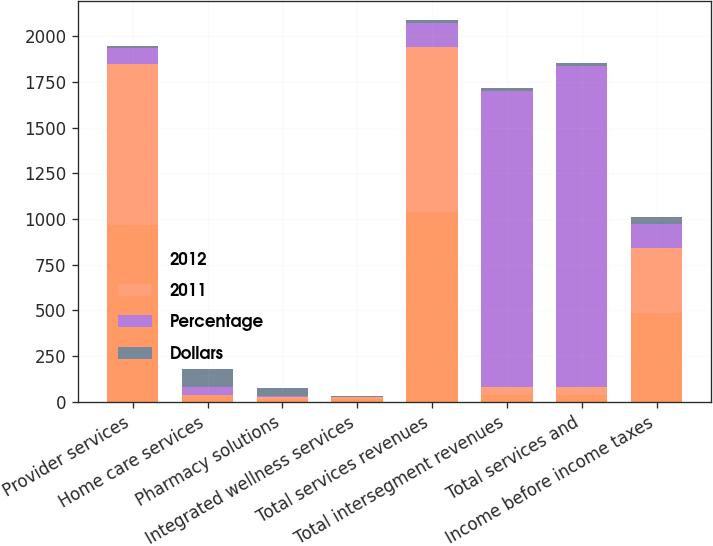<chart> <loc_0><loc_0><loc_500><loc_500><stacked_bar_chart><ecel><fcel>Provider services<fcel>Home care services<fcel>Pharmacy solutions<fcel>Integrated wellness services<fcel>Total services revenues<fcel>Total intersegment revenues<fcel>Total services and<fcel>Income before income taxes<nl><fcel>2012<fcel>967<fcel>40<fcel>16<fcel>13<fcel>1036<fcel>40<fcel>40<fcel>486<nl><fcel>2011<fcel>880<fcel>0<fcel>11<fcel>12<fcel>903<fcel>40<fcel>40<fcel>353<nl><fcel>Percentage<fcel>87<fcel>40<fcel>5<fcel>1<fcel>133<fcel>1622<fcel>1755<fcel>133<nl><fcel>Dollars<fcel>9.9<fcel>100<fcel>45.5<fcel>8.3<fcel>14.7<fcel>15.7<fcel>15.6<fcel>37.7<nl></chart> 